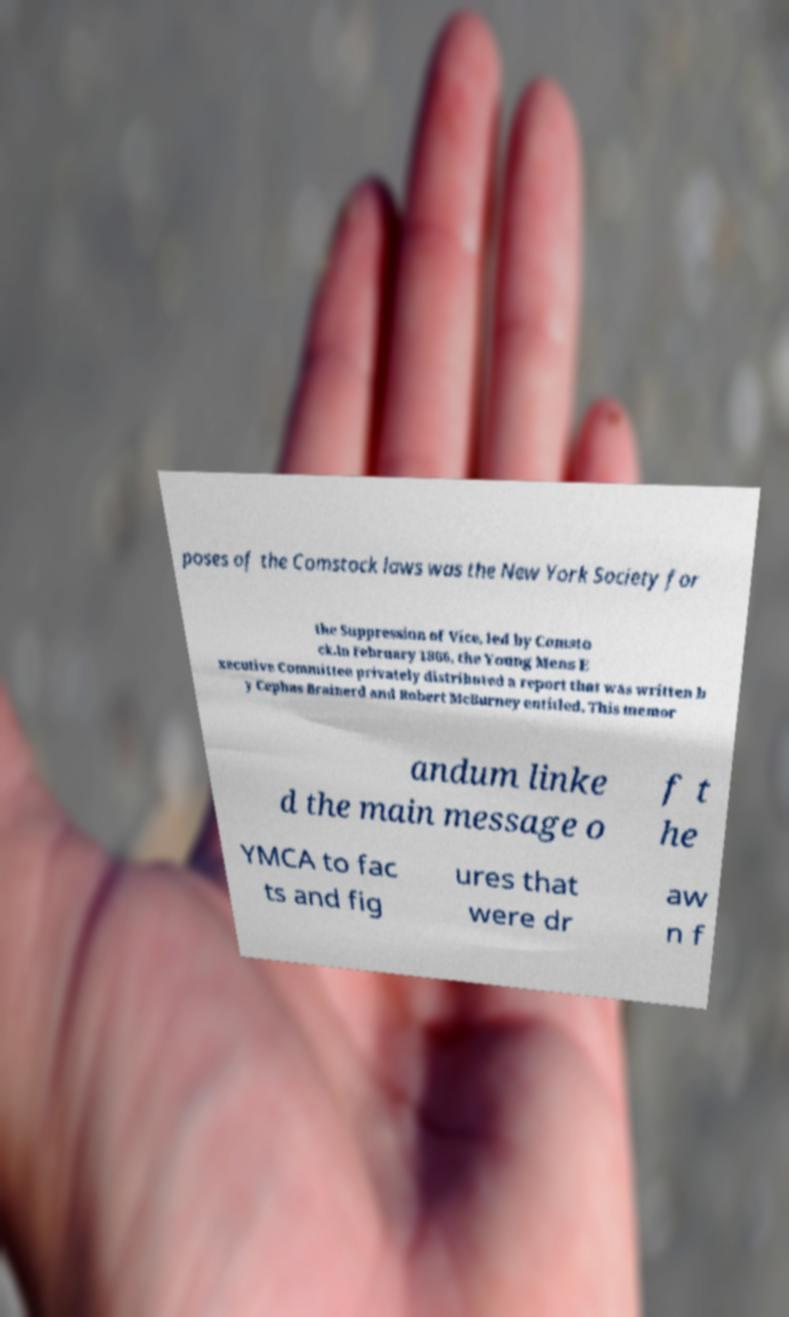Please read and relay the text visible in this image. What does it say? poses of the Comstock laws was the New York Society for the Suppression of Vice, led by Comsto ck.In February 1866, the Young Mens E xecutive Committee privately distributed a report that was written b y Cephas Brainerd and Robert McBurney entitled, This memor andum linke d the main message o f t he YMCA to fac ts and fig ures that were dr aw n f 